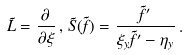<formula> <loc_0><loc_0><loc_500><loc_500>\tilde { L } = \frac { \partial } { \partial \xi } \, , \, \tilde { S } ( \tilde { f } ) = \frac { \tilde { f } ^ { \prime } } { \xi _ { y } \tilde { f } ^ { \prime } - \eta _ { y } } \, .</formula> 